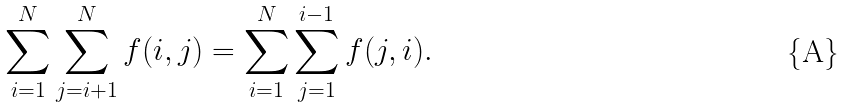Convert formula to latex. <formula><loc_0><loc_0><loc_500><loc_500>\sum _ { i = 1 } ^ { N } \sum _ { j = i + 1 } ^ { N } f ( i , j ) = \sum _ { i = 1 } ^ { N } \sum _ { j = 1 } ^ { i - 1 } f ( j , i ) .</formula> 